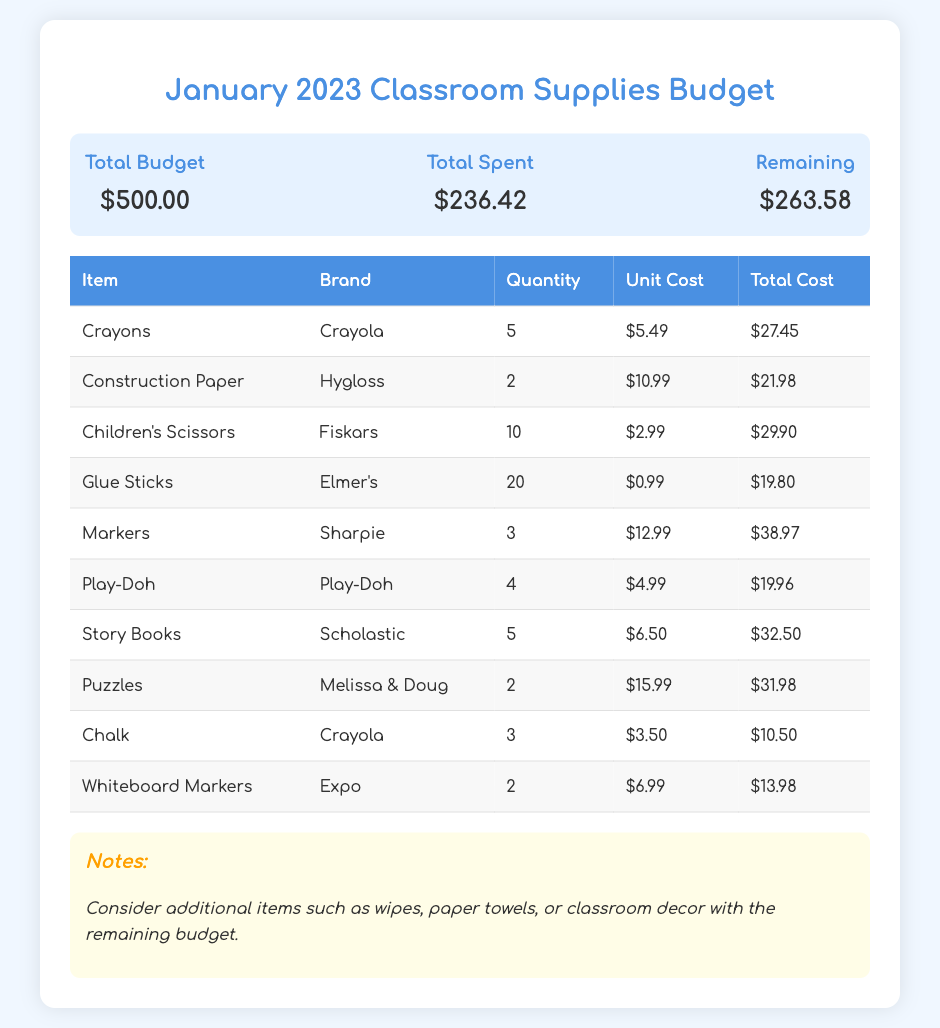What is the total budget for January 2023? The total budget is stated directly in the document under "Total Budget."
Answer: $500.00 How much was spent on glue sticks? The total cost of glue sticks is calculated and shown in the itemized table.
Answer: $19.80 What is the quantity of crayons purchased? The quantity of crayons is listed in the itemized table under the "Quantity" column for crayons.
Answer: 5 Which brand was used for markers? The brand for markers is provided in the itemized table next to the markers item.
Answer: Sharpie What is the remaining budget after expenses? The remaining budget is calculated by subtracting the total spent from the total budget.
Answer: $263.58 How many different types of items are listed in the budget? The number of item rows in the table indicates the types of items listed.
Answer: 10 What is the total spent in January 2023? The total spent is shown directly in the document under "Total Spent."
Answer: $236.42 What is one suggestion mentioned in the notes section? The notes provide suggestions based on the remaining budget for additional supplies.
Answer: Wipes How much did the puzzles cost in total? The total cost for puzzles is calculated in the itemized table specifically for that item.
Answer: $31.98 